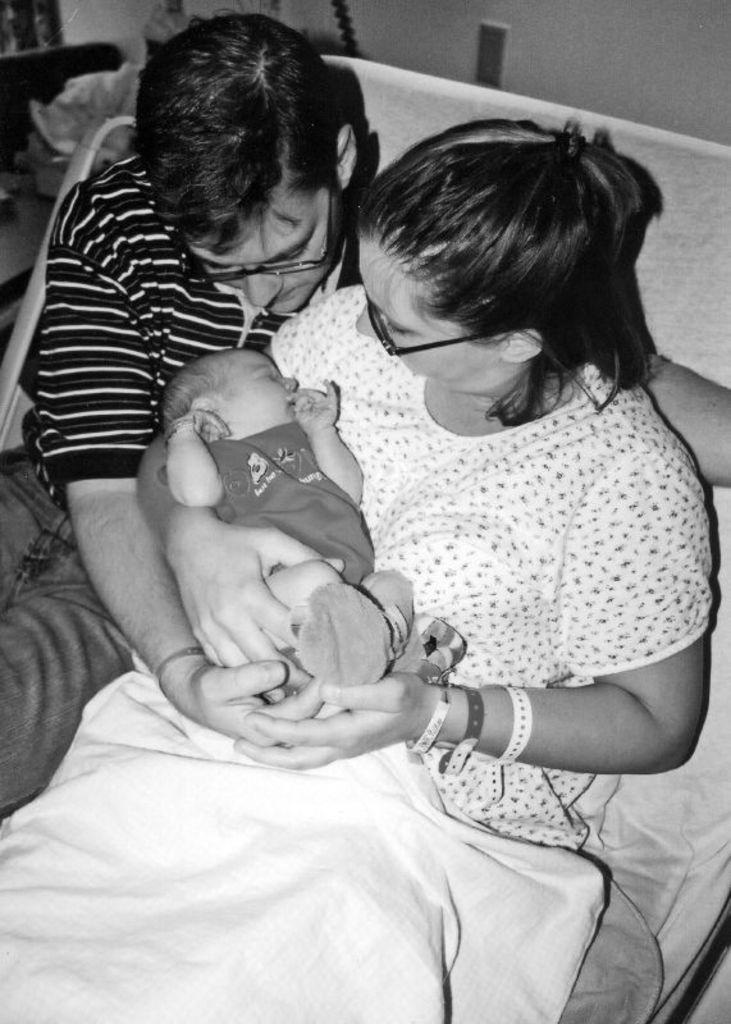In one or two sentences, can you explain what this image depicts? In this picture we can see a man, a woman and a baby here, there is a bed sheet here, in the background there is a wall. 